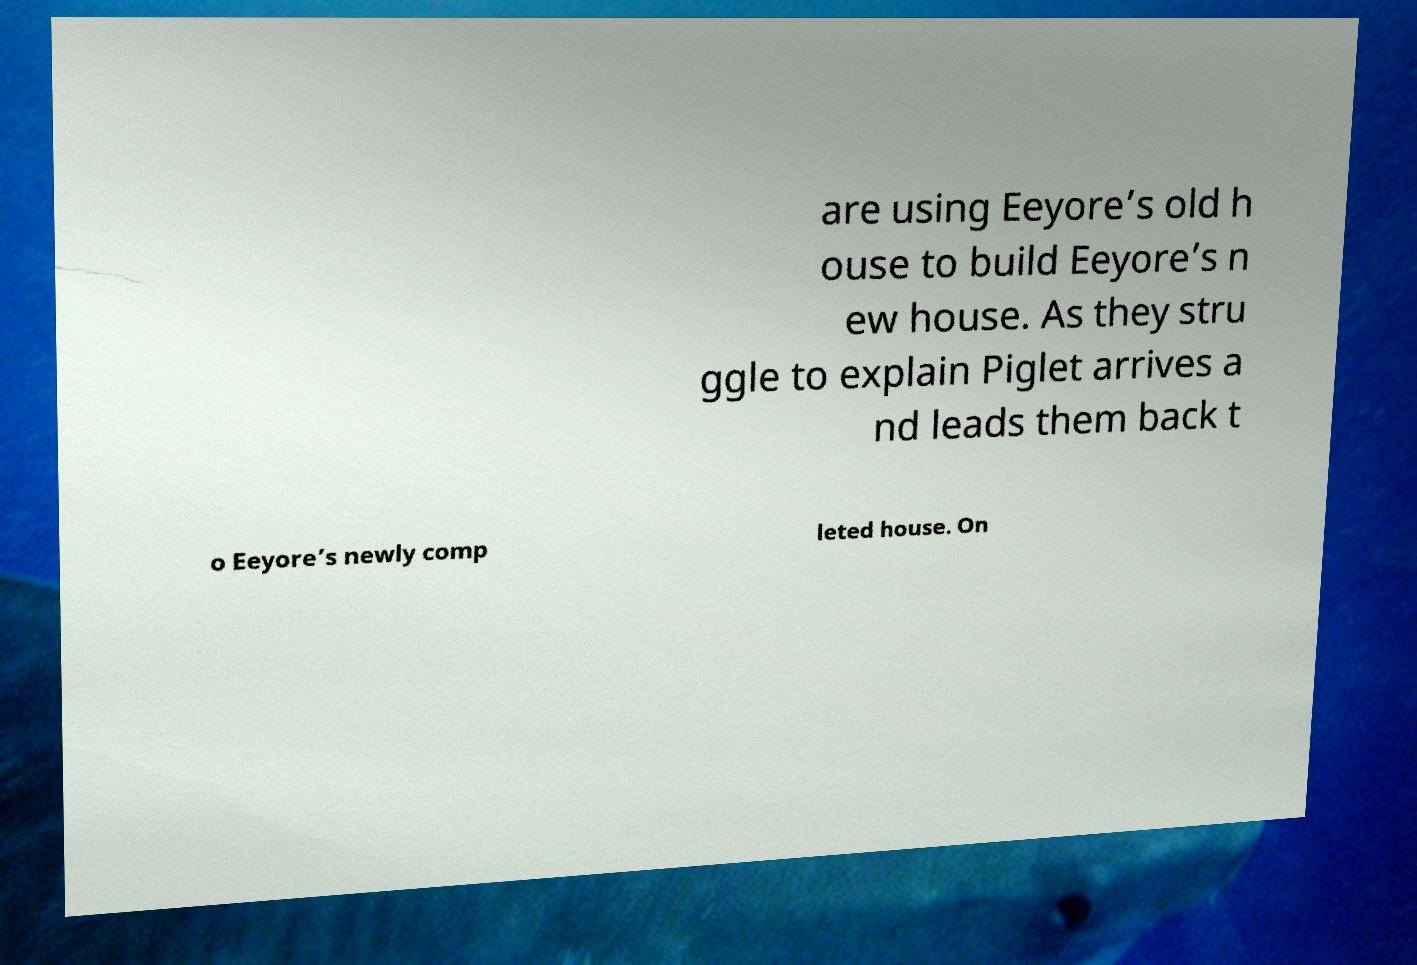There's text embedded in this image that I need extracted. Can you transcribe it verbatim? are using Eeyore’s old h ouse to build Eeyore’s n ew house. As they stru ggle to explain Piglet arrives a nd leads them back t o Eeyore’s newly comp leted house. On 